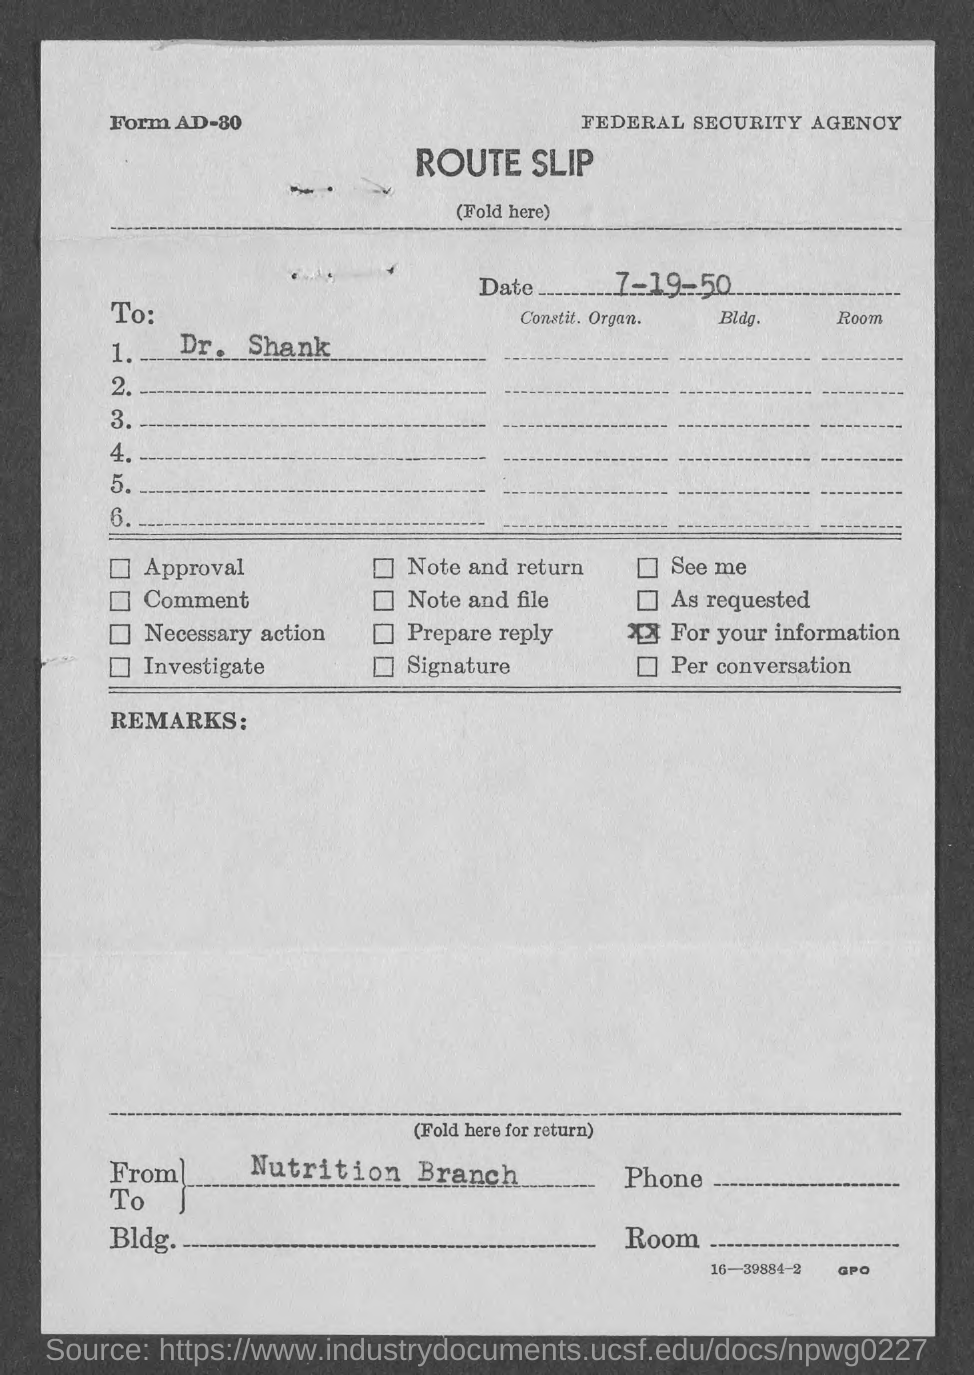Specify some key components in this picture. The date is July 19th, 1950. The letter is addressed to Dr. Shank. 